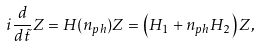Convert formula to latex. <formula><loc_0><loc_0><loc_500><loc_500>i \frac { d } { d \tilde { t } } Z = H ( n _ { p h } ) Z = \left ( H _ { 1 } + n _ { p h } H _ { 2 } \right ) Z ,</formula> 